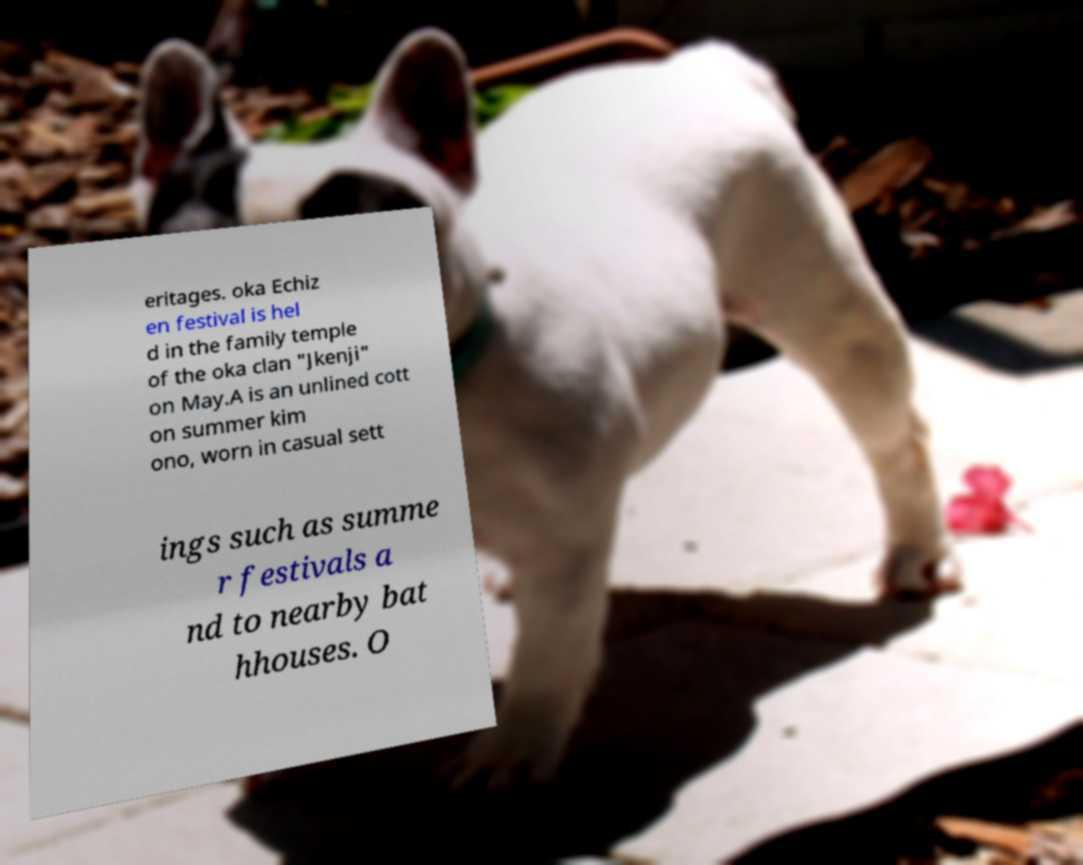Can you accurately transcribe the text from the provided image for me? eritages. oka Echiz en festival is hel d in the family temple of the oka clan "Jkenji" on May.A is an unlined cott on summer kim ono, worn in casual sett ings such as summe r festivals a nd to nearby bat hhouses. O 